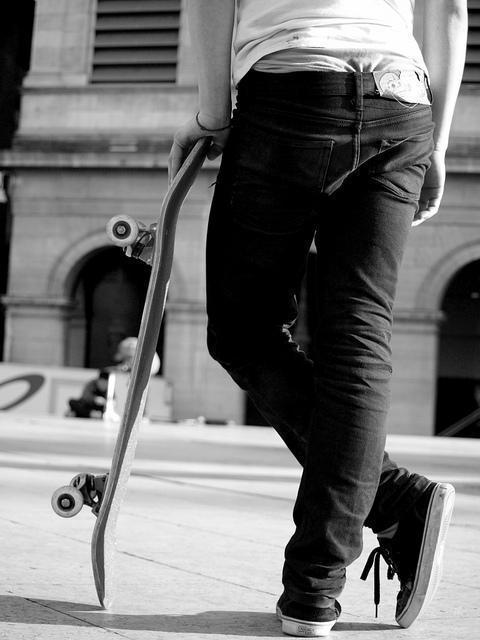What can the object the person is leaning on be used for?
From the following four choices, select the correct answer to address the question.
Options: Running, transportation, swimming, flying. Transportation. 